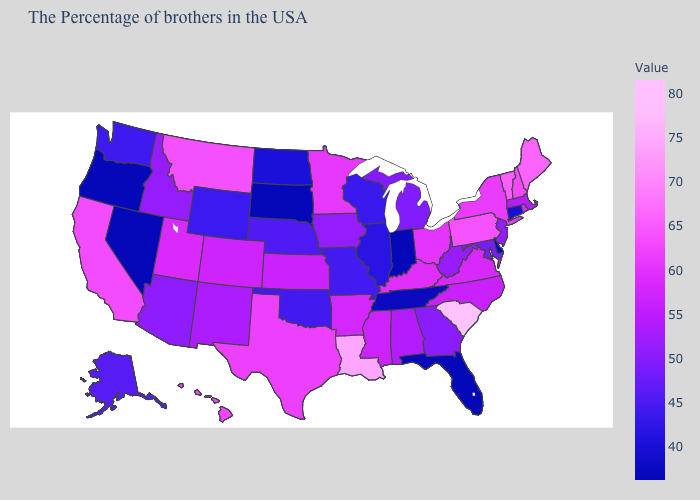Among the states that border Pennsylvania , does New York have the highest value?
Quick response, please. Yes. Among the states that border South Carolina , which have the lowest value?
Answer briefly. Georgia. Among the states that border West Virginia , which have the lowest value?
Answer briefly. Maryland. Does California have a higher value than Louisiana?
Keep it brief. No. Does the map have missing data?
Give a very brief answer. No. Does Louisiana have a lower value than Arkansas?
Short answer required. No. Among the states that border North Dakota , which have the highest value?
Answer briefly. Montana. Which states have the lowest value in the USA?
Write a very short answer. Delaware, Florida, Indiana, South Dakota, Nevada, Oregon. Among the states that border Vermont , does New Hampshire have the highest value?
Quick response, please. Yes. 